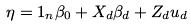<formula> <loc_0><loc_0><loc_500><loc_500>\eta = 1 _ { n } \beta _ { 0 } + X _ { d } \beta _ { d } + Z _ { d } u _ { d }</formula> 